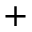<formula> <loc_0><loc_0><loc_500><loc_500>^ { + }</formula> 